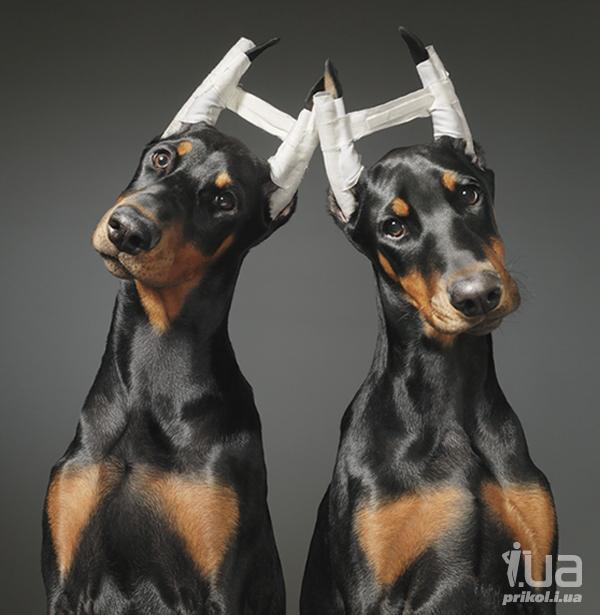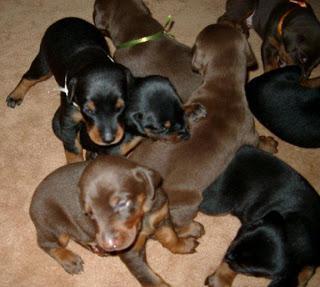The first image is the image on the left, the second image is the image on the right. For the images displayed, is the sentence "There are more dogs in the image on the right." factually correct? Answer yes or no. Yes. The first image is the image on the left, the second image is the image on the right. Considering the images on both sides, is "The left and right image contains the same number of dogs." valid? Answer yes or no. No. 